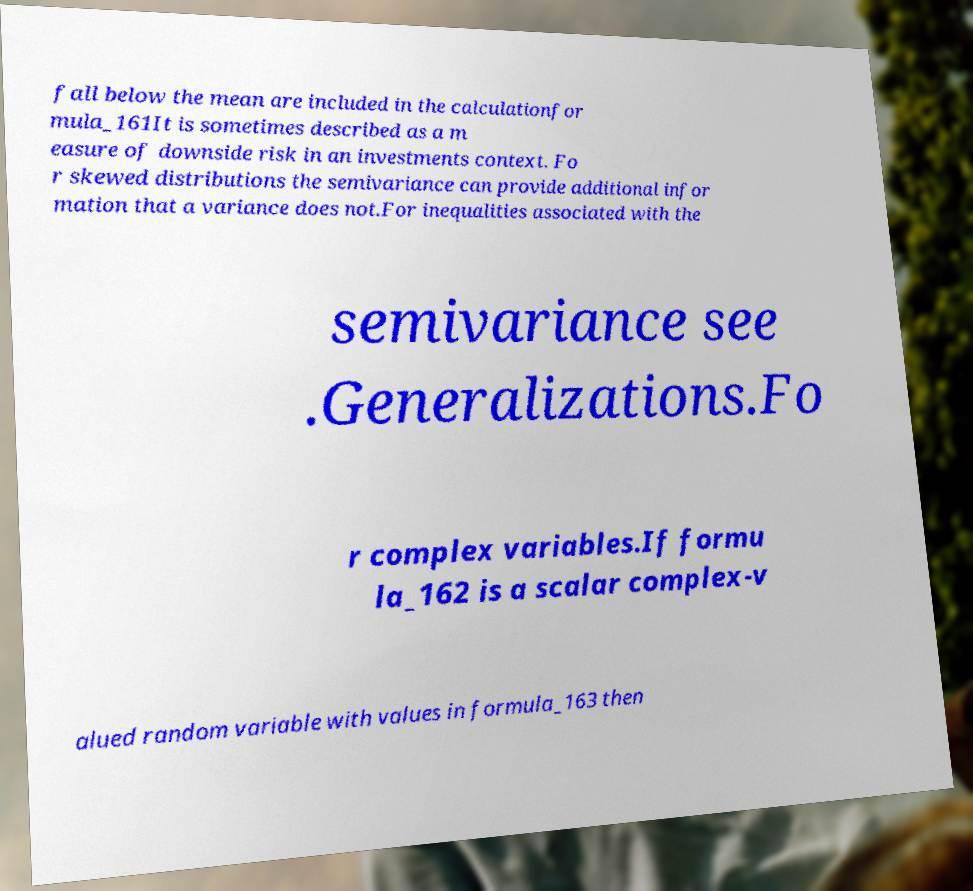Could you assist in decoding the text presented in this image and type it out clearly? fall below the mean are included in the calculationfor mula_161It is sometimes described as a m easure of downside risk in an investments context. Fo r skewed distributions the semivariance can provide additional infor mation that a variance does not.For inequalities associated with the semivariance see .Generalizations.Fo r complex variables.If formu la_162 is a scalar complex-v alued random variable with values in formula_163 then 